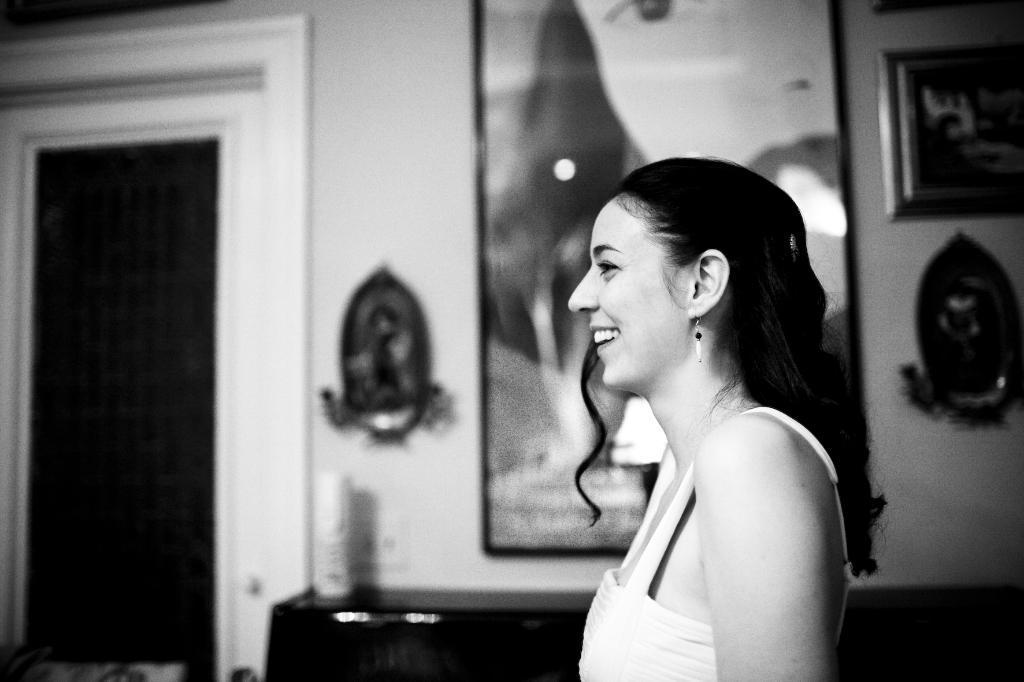Can you describe this image briefly? In this image I can see a person standing. Background I can see few frames attached to the wall and a door, and the image is in black and white. 